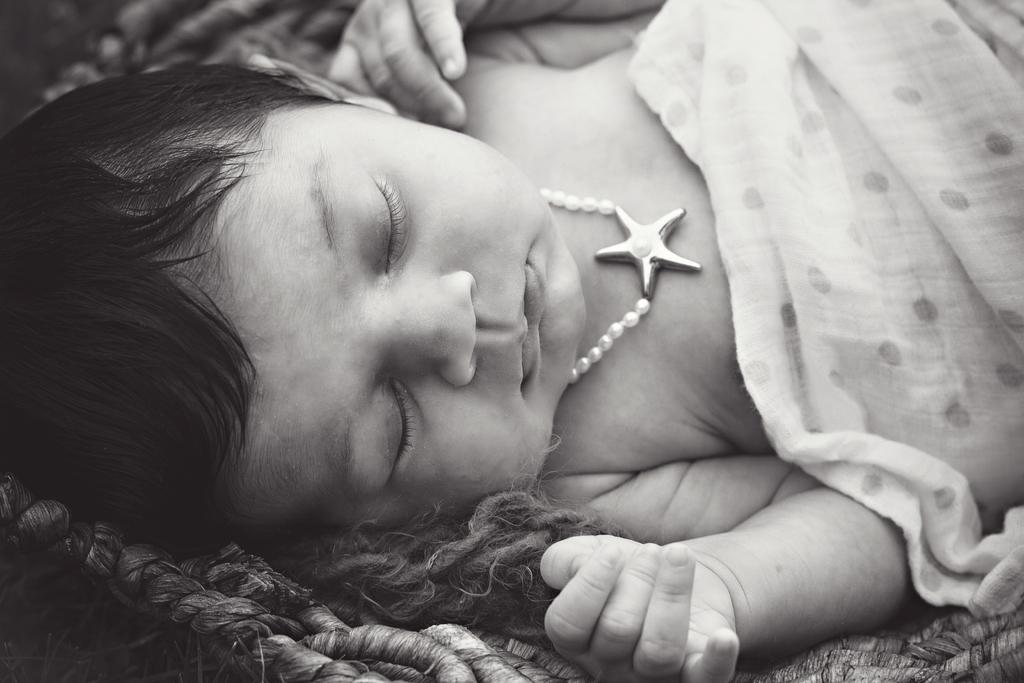What is the main subject of the image? There is a child lying in the image. What can be seen on the right side of the image? There is a cloth on the right side of the image. What color scheme is used in the image? The image is black and white. What type of potato is being whipped in the hall in the image? There is no potato or whip present in the image, and no hall is depicted. 